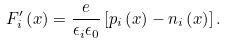Convert formula to latex. <formula><loc_0><loc_0><loc_500><loc_500>F _ { i } ^ { \prime } \left ( x \right ) = \frac { e } { \epsilon _ { i } \epsilon _ { 0 } } \left [ p _ { i } \left ( x \right ) - n _ { i } \left ( x \right ) \right ] .</formula> 